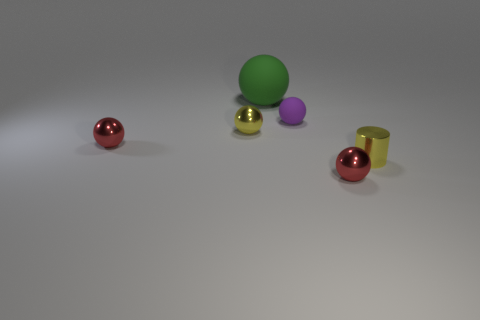Is there a shiny cylinder?
Offer a very short reply. Yes. What number of other objects are the same material as the yellow cylinder?
Provide a short and direct response. 3. What is the material of the purple sphere that is the same size as the cylinder?
Provide a short and direct response. Rubber. Do the tiny yellow metallic thing to the right of the purple rubber thing and the purple rubber object have the same shape?
Your response must be concise. No. Is the large object the same color as the small matte object?
Provide a short and direct response. No. What number of things are objects in front of the large rubber object or small purple things?
Give a very brief answer. 5. What is the shape of the purple object that is the same size as the shiny cylinder?
Your answer should be compact. Sphere. Is the size of the red metallic thing that is to the left of the purple matte object the same as the matte thing behind the tiny purple ball?
Keep it short and to the point. No. The thing that is the same material as the large green ball is what color?
Make the answer very short. Purple. Does the red sphere that is on the left side of the large matte object have the same material as the green ball that is behind the tiny yellow metal cylinder?
Offer a terse response. No. 